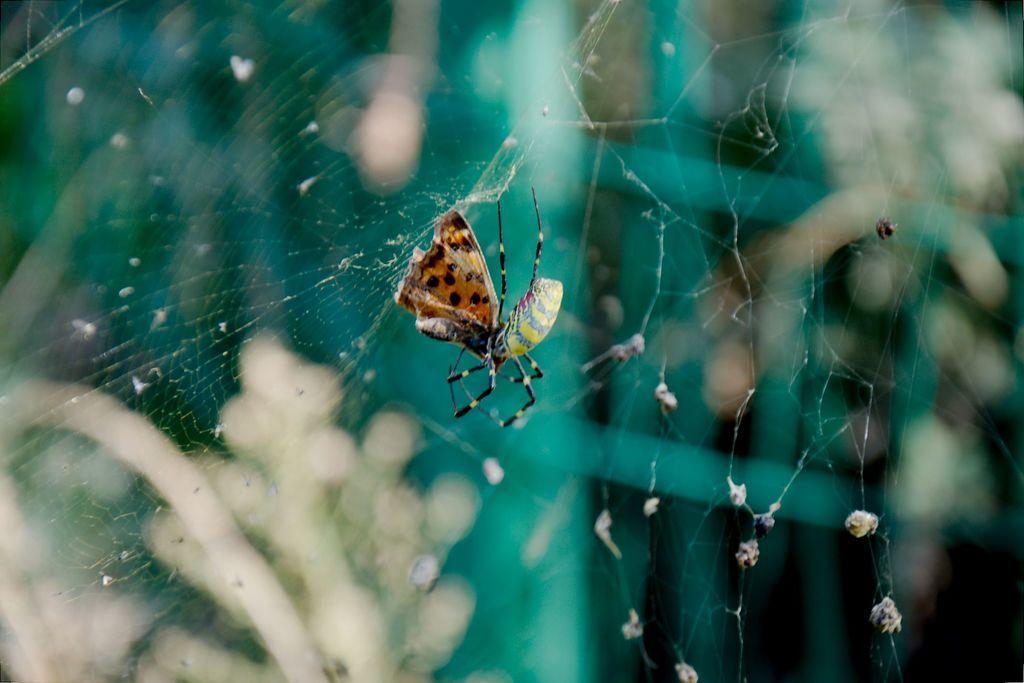Please provide a concise description of this image. In this image we can see a spider and a butterfly on the web. 